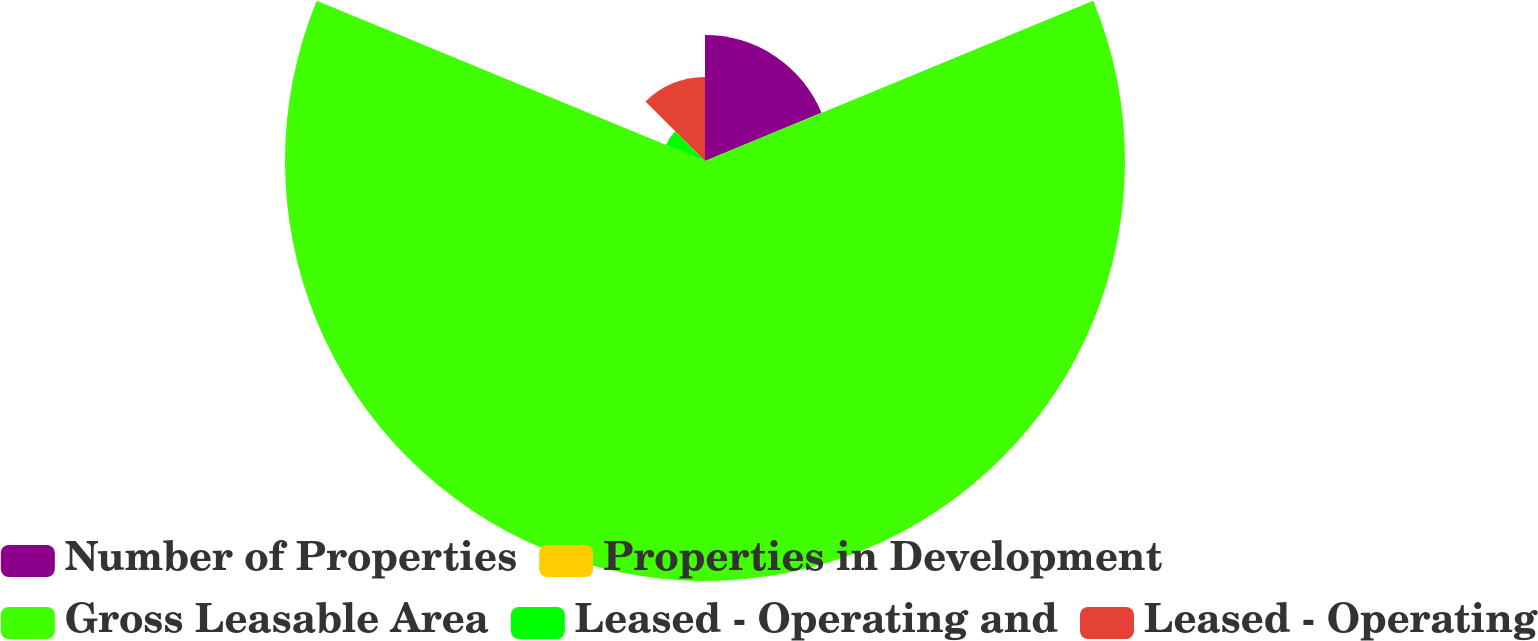Convert chart to OTSL. <chart><loc_0><loc_0><loc_500><loc_500><pie_chart><fcel>Number of Properties<fcel>Properties in Development<fcel>Gross Leasable Area<fcel>Leased - Operating and<fcel>Leased - Operating<nl><fcel>18.75%<fcel>0.02%<fcel>62.46%<fcel>6.26%<fcel>12.51%<nl></chart> 